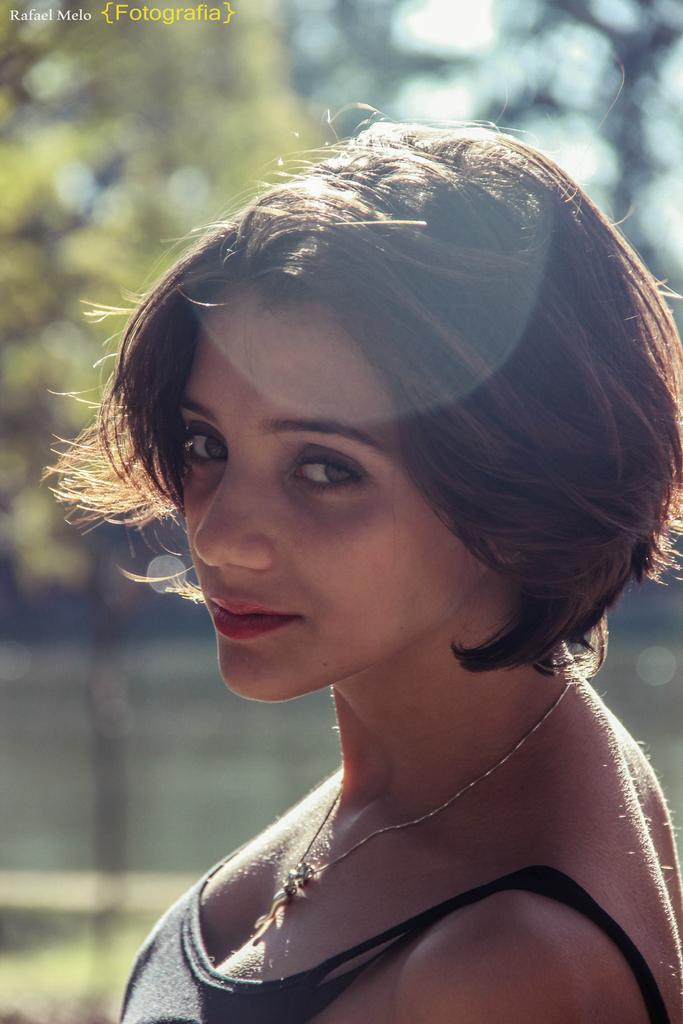Who is in the image? There is a woman in the image. What is the woman doing in the image? The woman is standing. What is the woman wearing in the image? The woman is wearing a black top. How is the woman's hair styled in the image? The woman has a short haircut. What can be seen in the background of the image? There is grass, a tree, and the sky visible in the background of the image. What scientific experiment is the woman attempting to produce in the image? There is no indication of a scientific experiment or any attempt to produce one in the image. 